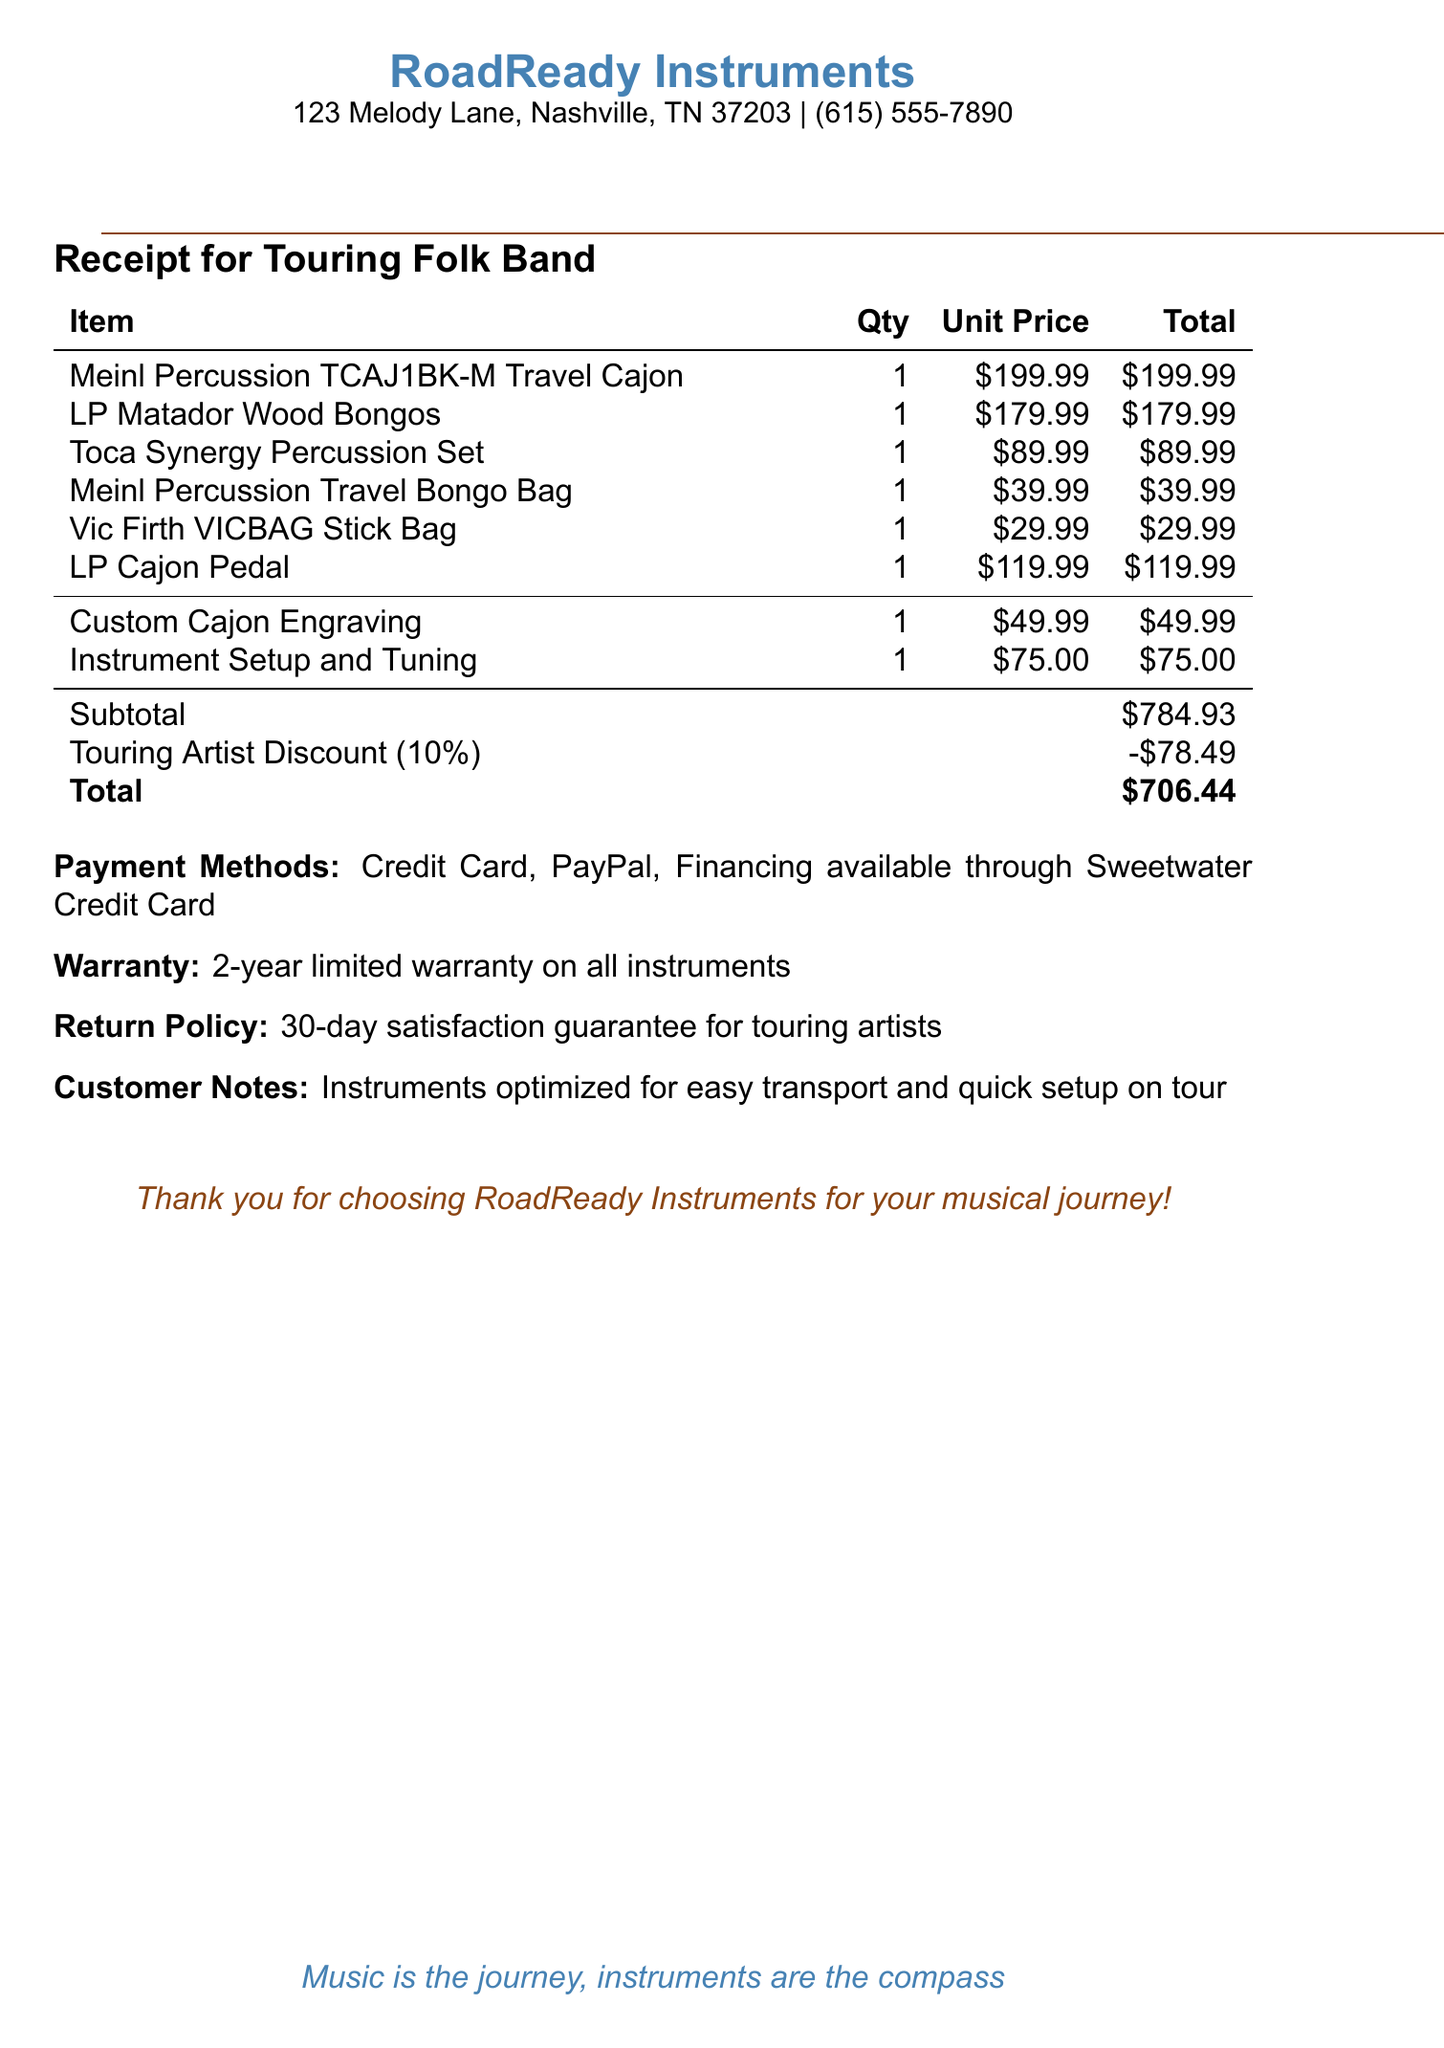What is the vendor's name? The vendor's name is clearly stated at the top of the receipt.
Answer: RoadReady Instruments What is the total amount due? The total amount due is mentioned at the bottom of the receipt.
Answer: $706.44 How many items were purchased in total? The receipt lists the items and shows their quantity.
Answer: 6 What is the address of the vendor? The address is provided at the beginning of the document.
Answer: 123 Melody Lane, Nashville, TN 37203 What discount was applied to the purchase? The document specifies the discount that was applied to the total.
Answer: 10% What is the warranty duration for the instruments? The warranty information is provided within the document.
Answer: 2-year limited warranty What additional service is offered at $75? The receipt mentions various services, including one with this specific price.
Answer: Instrument Setup and Tuning How much does the custom cajon engraving cost? The cost of this service is listed in the additional services section.
Answer: $49.99 What payment methods are accepted? The receipt includes a list of the accepted payment methods.
Answer: Credit Card, PayPal, Financing available through Sweetwater Credit Card What is the return policy for touring artists? The receipt outlines a specific return policy for a specific group of customers.
Answer: 30-day satisfaction guarantee for touring artists 